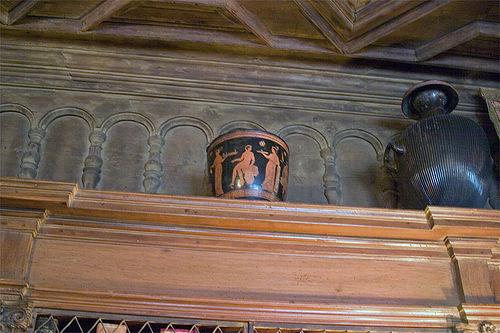Was this photo likely taken in the Mediterranean?
Write a very short answer. Yes. Is this an antique clock?
Concise answer only. No. What are the colors of the smaller vase?
Short answer required. Brown and black. Would the vases break if they fell?
Give a very brief answer. Yes. What does the figure depict?
Quick response, please. Art. 